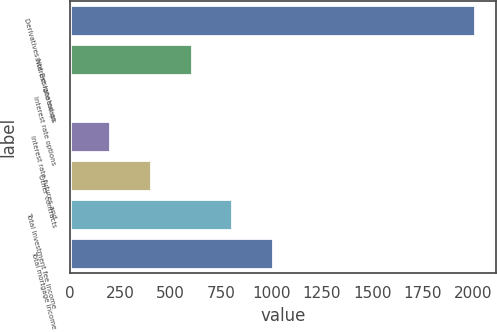Convert chart to OTSL. <chart><loc_0><loc_0><loc_500><loc_500><bar_chart><fcel>Derivatives Not Designated as<fcel>Interest rate swaps<fcel>Interest rate options<fcel>Interest rate futures and<fcel>Other contracts<fcel>Total investment fee income<fcel>Total mortgage income<nl><fcel>2012<fcel>604.3<fcel>1<fcel>202.1<fcel>403.2<fcel>805.4<fcel>1006.5<nl></chart> 